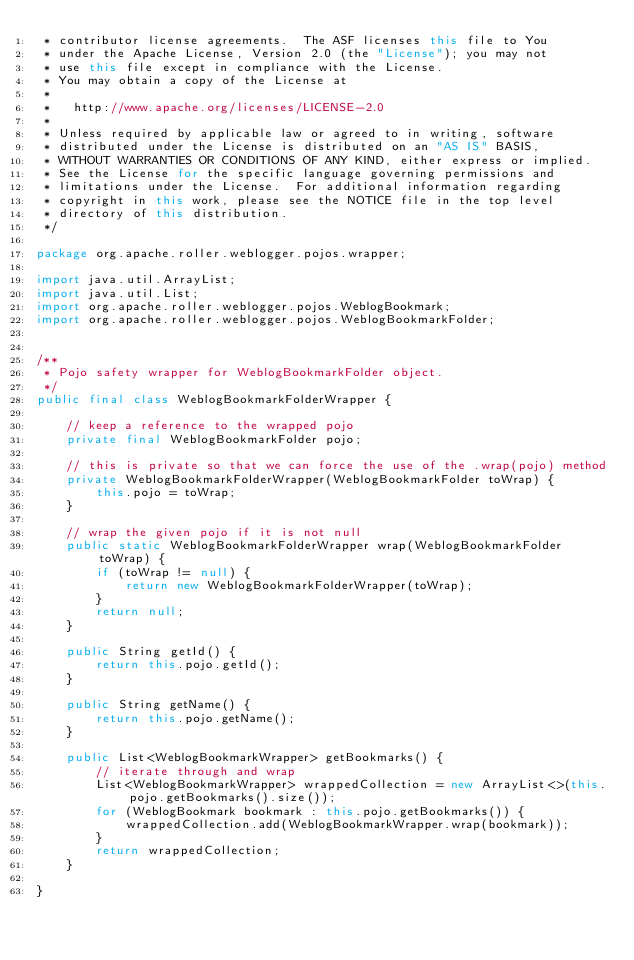Convert code to text. <code><loc_0><loc_0><loc_500><loc_500><_Java_> * contributor license agreements.  The ASF licenses this file to You
 * under the Apache License, Version 2.0 (the "License"); you may not
 * use this file except in compliance with the License.
 * You may obtain a copy of the License at
 *
 *   http://www.apache.org/licenses/LICENSE-2.0
 *
 * Unless required by applicable law or agreed to in writing, software
 * distributed under the License is distributed on an "AS IS" BASIS,
 * WITHOUT WARRANTIES OR CONDITIONS OF ANY KIND, either express or implied.
 * See the License for the specific language governing permissions and
 * limitations under the License.  For additional information regarding
 * copyright in this work, please see the NOTICE file in the top level
 * directory of this distribution.
 */

package org.apache.roller.weblogger.pojos.wrapper;

import java.util.ArrayList;
import java.util.List;
import org.apache.roller.weblogger.pojos.WeblogBookmark;
import org.apache.roller.weblogger.pojos.WeblogBookmarkFolder;


/**
 * Pojo safety wrapper for WeblogBookmarkFolder object.
 */
public final class WeblogBookmarkFolderWrapper {
    
    // keep a reference to the wrapped pojo
    private final WeblogBookmarkFolder pojo;
    
    // this is private so that we can force the use of the .wrap(pojo) method
    private WeblogBookmarkFolderWrapper(WeblogBookmarkFolder toWrap) {
        this.pojo = toWrap;
    }

    // wrap the given pojo if it is not null
    public static WeblogBookmarkFolderWrapper wrap(WeblogBookmarkFolder toWrap) {
        if (toWrap != null) {
            return new WeblogBookmarkFolderWrapper(toWrap);
        }
        return null;
    }

    public String getId() {
        return this.pojo.getId();
    }

    public String getName() {
        return this.pojo.getName();
    }

    public List<WeblogBookmarkWrapper> getBookmarks() {
        // iterate through and wrap
        List<WeblogBookmarkWrapper> wrappedCollection = new ArrayList<>(this.pojo.getBookmarks().size());
        for (WeblogBookmark bookmark : this.pojo.getBookmarks()) {
            wrappedCollection.add(WeblogBookmarkWrapper.wrap(bookmark));
        }
        return wrappedCollection;
    }    

}
</code> 